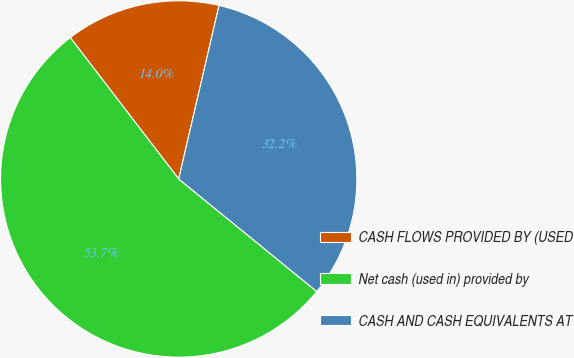Convert chart. <chart><loc_0><loc_0><loc_500><loc_500><pie_chart><fcel>CASH FLOWS PROVIDED BY (USED<fcel>Net cash (used in) provided by<fcel>CASH AND CASH EQUIVALENTS AT<nl><fcel>14.05%<fcel>53.71%<fcel>32.25%<nl></chart> 